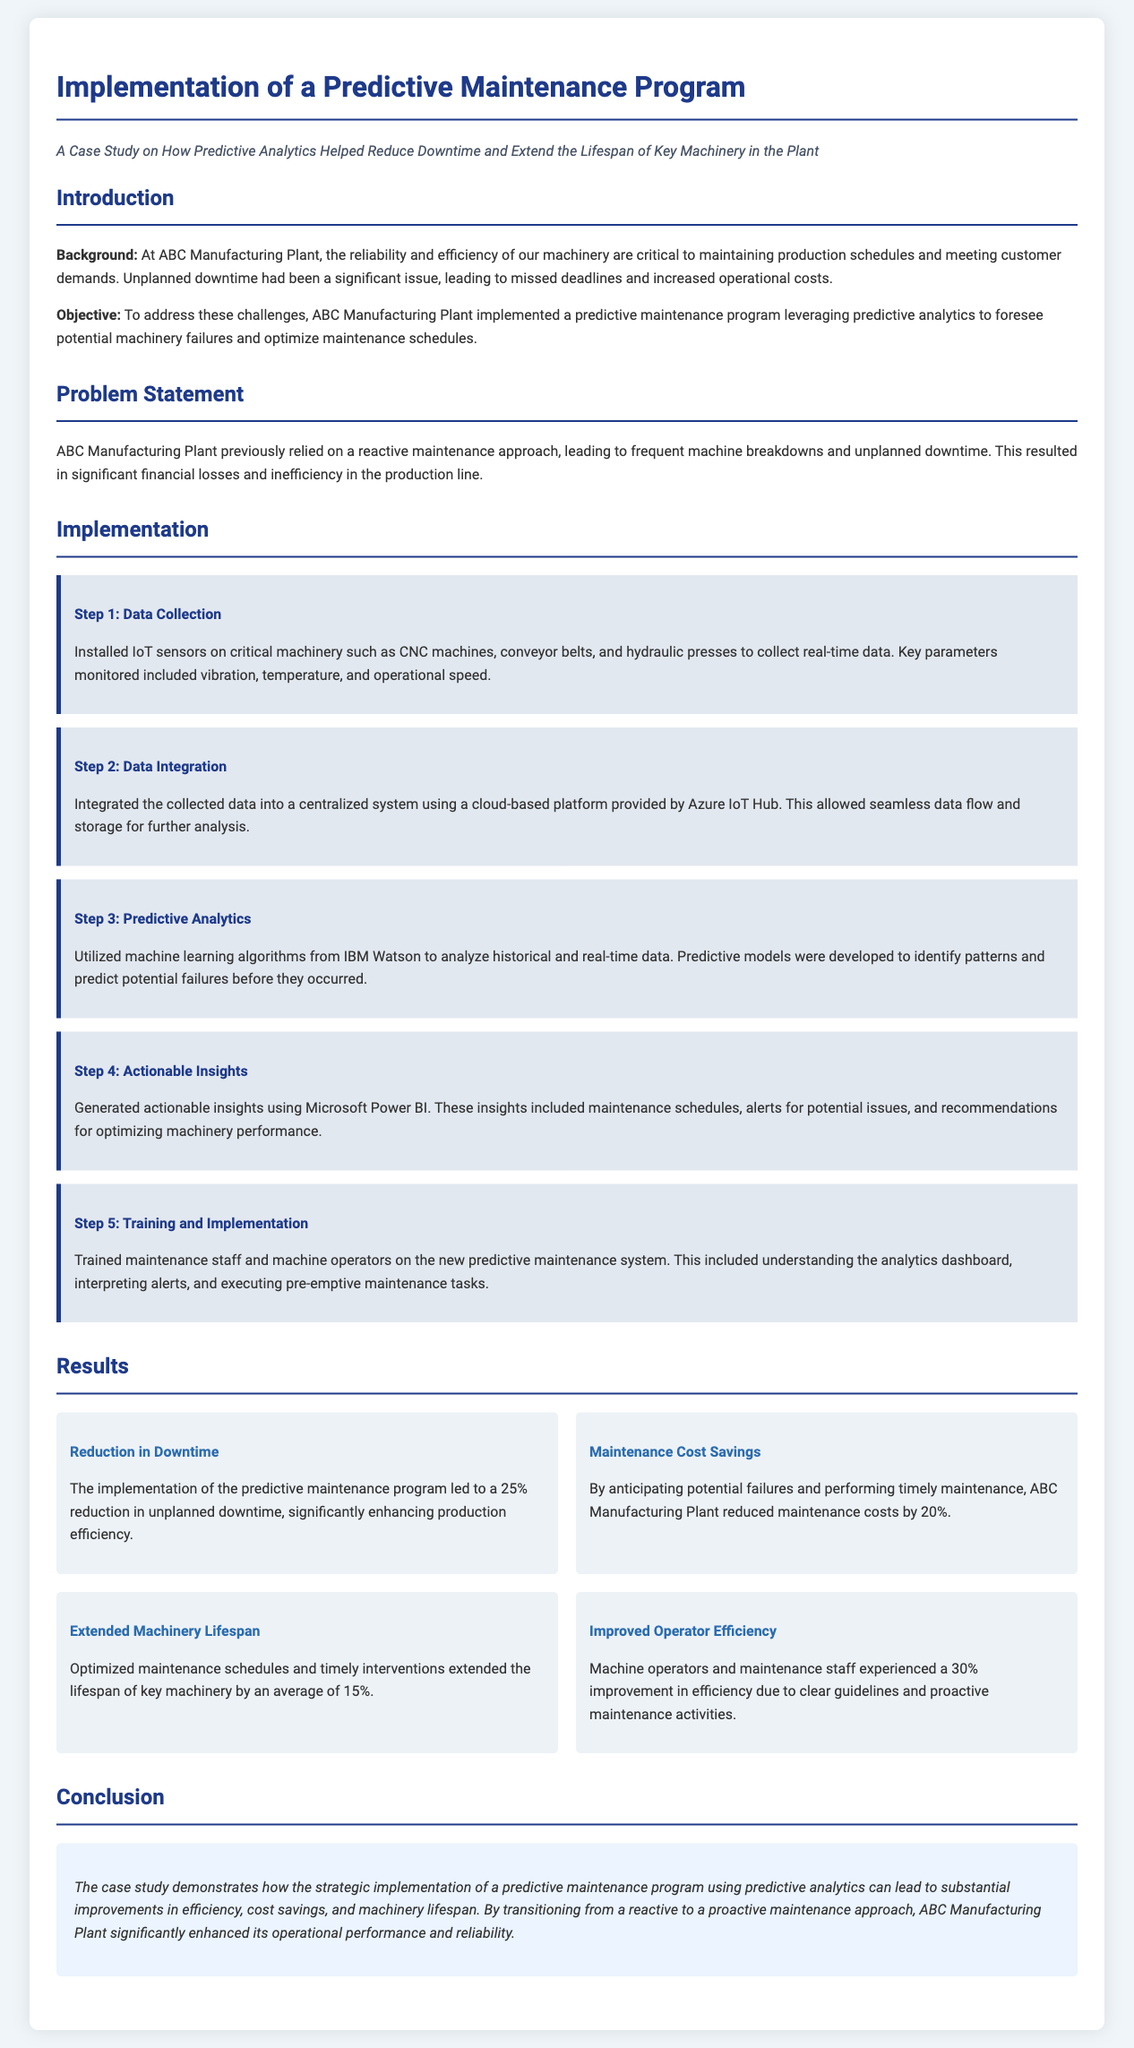What was the percentage reduction in unplanned downtime? The document states that the implementation led to a 25% reduction in unplanned downtime, significantly enhancing production efficiency.
Answer: 25% Which platform was used for data integration? The case study mentions that a cloud-based platform provided by Azure IoT Hub was utilized for data integration.
Answer: Azure IoT Hub What is the average lifespan extension of key machinery? According to the results, optimized maintenance schedules and timely interventions extended the lifespan of key machinery by an average of 15%.
Answer: 15% What was the percentage reduction in maintenance costs? The document indicates that maintenance costs were reduced by 20% due to anticipating potential failures and performing timely maintenance.
Answer: 20% What technology was used for predictive analytics? The case study reveals that machine learning algorithms from IBM Watson were used for predictive analytics.
Answer: IBM Watson What was one of the key parameters monitored by IoT sensors? The document lists vibration as one of the key parameters monitored via IoT sensors installed on critical machinery.
Answer: Vibration What improvement in operator efficiency was reported? The case study reports a 30% improvement in efficiency for machine operators and maintenance staff.
Answer: 30% What approach was previously relied upon for maintenance? The document states that ABC Manufacturing Plant previously relied on a reactive maintenance approach leading to frequent breakdowns.
Answer: Reactive maintenance What is the main benefit of the predictive maintenance program as concluded in the document? The conclusion emphasizes that the strategic implementation leads to substantial improvements in efficiency, cost savings, and machinery lifespan.
Answer: Substantial improvements 